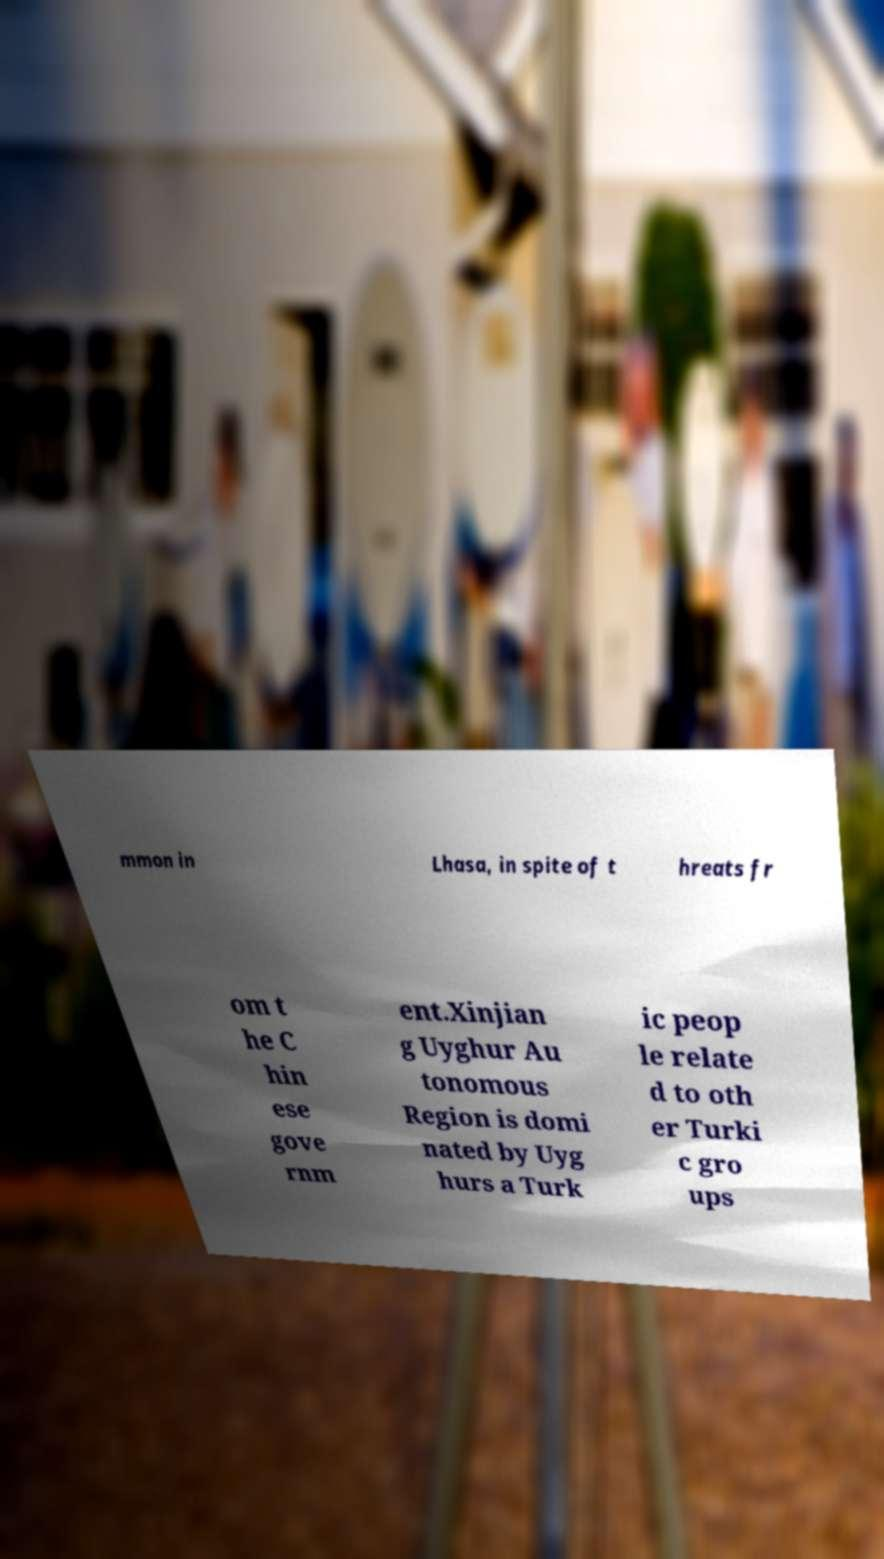Can you accurately transcribe the text from the provided image for me? mmon in Lhasa, in spite of t hreats fr om t he C hin ese gove rnm ent.Xinjian g Uyghur Au tonomous Region is domi nated by Uyg hurs a Turk ic peop le relate d to oth er Turki c gro ups 